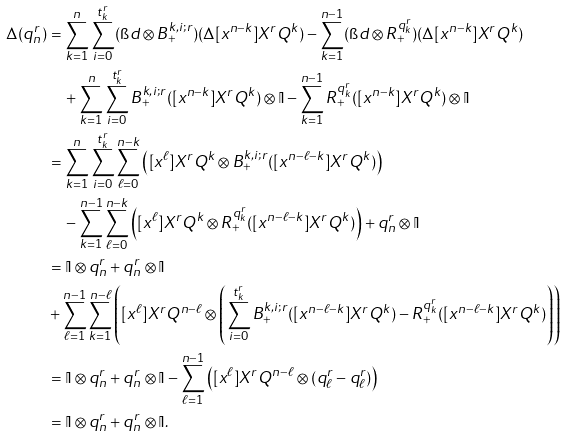Convert formula to latex. <formula><loc_0><loc_0><loc_500><loc_500>\Delta ( q _ { n } ^ { r } ) & = \sum _ { k = 1 } ^ { n } \sum _ { i = 0 } ^ { t ^ { r } _ { k } } ( \i d \otimes B _ { + } ^ { k , i ; r } ) ( \Delta [ x ^ { n - k } ] X ^ { r } Q ^ { k } ) - \sum _ { k = 1 } ^ { n - 1 } ( \i d \otimes R _ { + } ^ { q ^ { r } _ { k } } ) ( \Delta [ x ^ { n - k } ] X ^ { r } Q ^ { k } ) \\ & \quad + \sum _ { k = 1 } ^ { n } \sum _ { i = 0 } ^ { t ^ { r } _ { k } } B _ { + } ^ { k , i ; r } ( [ x ^ { n - k } ] X ^ { r } Q ^ { k } ) \otimes \mathbb { I } - \sum _ { k = 1 } ^ { n - 1 } R _ { + } ^ { q ^ { r } _ { k } } ( [ x ^ { n - k } ] X ^ { r } Q ^ { k } ) \otimes \mathbb { I } \\ & = \sum _ { k = 1 } ^ { n } \sum _ { i = 0 } ^ { t ^ { r } _ { k } } \sum _ { \ell = 0 } ^ { n - k } \left ( [ x ^ { \ell } ] X ^ { r } Q ^ { k } \otimes B _ { + } ^ { k , i ; r } ( [ x ^ { n - \ell - k } ] X ^ { r } Q ^ { k } ) \right ) \\ & \quad - \sum _ { k = 1 } ^ { n - 1 } \sum _ { \ell = 0 } ^ { n - k } \left ( [ x ^ { \ell } ] X ^ { r } Q ^ { k } \otimes R _ { + } ^ { q ^ { r } _ { k } } ( [ x ^ { n - \ell - k } ] X ^ { r } Q ^ { k } ) \right ) + q ^ { r } _ { n } \otimes \mathbb { I } \\ & = \mathbb { I } \otimes q ^ { r } _ { n } + q ^ { r } _ { n } \otimes \mathbb { I } \\ & + \sum _ { \ell = 1 } ^ { n - 1 } \sum _ { k = 1 } ^ { n - \ell } \left ( [ x ^ { \ell } ] X ^ { r } Q ^ { n - \ell } \otimes \left ( \sum _ { i = 0 } ^ { t _ { k } ^ { r } } B _ { + } ^ { k , i ; r } ( [ x ^ { n - \ell - k } ] X ^ { r } Q ^ { k } ) - R _ { + } ^ { q ^ { r } _ { k } } ( [ x ^ { n - \ell - k } ] X ^ { r } Q ^ { k } ) \right ) \right ) \\ & = \mathbb { I } \otimes q ^ { r } _ { n } + q ^ { r } _ { n } \otimes \mathbb { I } - \sum _ { \ell = 1 } ^ { n - 1 } \left ( [ x ^ { \ell } ] X ^ { r } Q ^ { n - \ell } \otimes ( q _ { \ell } ^ { r } - q _ { \ell } ^ { r } ) \right ) \\ & = \mathbb { I } \otimes q _ { n } ^ { r } + q _ { n } ^ { r } \otimes \mathbb { I } .</formula> 